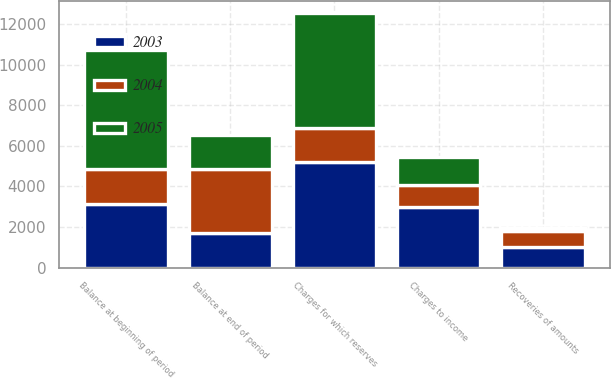<chart> <loc_0><loc_0><loc_500><loc_500><stacked_bar_chart><ecel><fcel>Balance at beginning of period<fcel>Charges to income<fcel>Recoveries of amounts<fcel>Charges for which reserves<fcel>Balance at end of period<nl><fcel>2003<fcel>3158<fcel>2998<fcel>1026<fcel>5225<fcel>1692<nl><fcel>2004<fcel>1692<fcel>1074<fcel>792<fcel>1640<fcel>3158<nl><fcel>2005<fcel>5890<fcel>1365<fcel>107<fcel>5670<fcel>1692<nl></chart> 